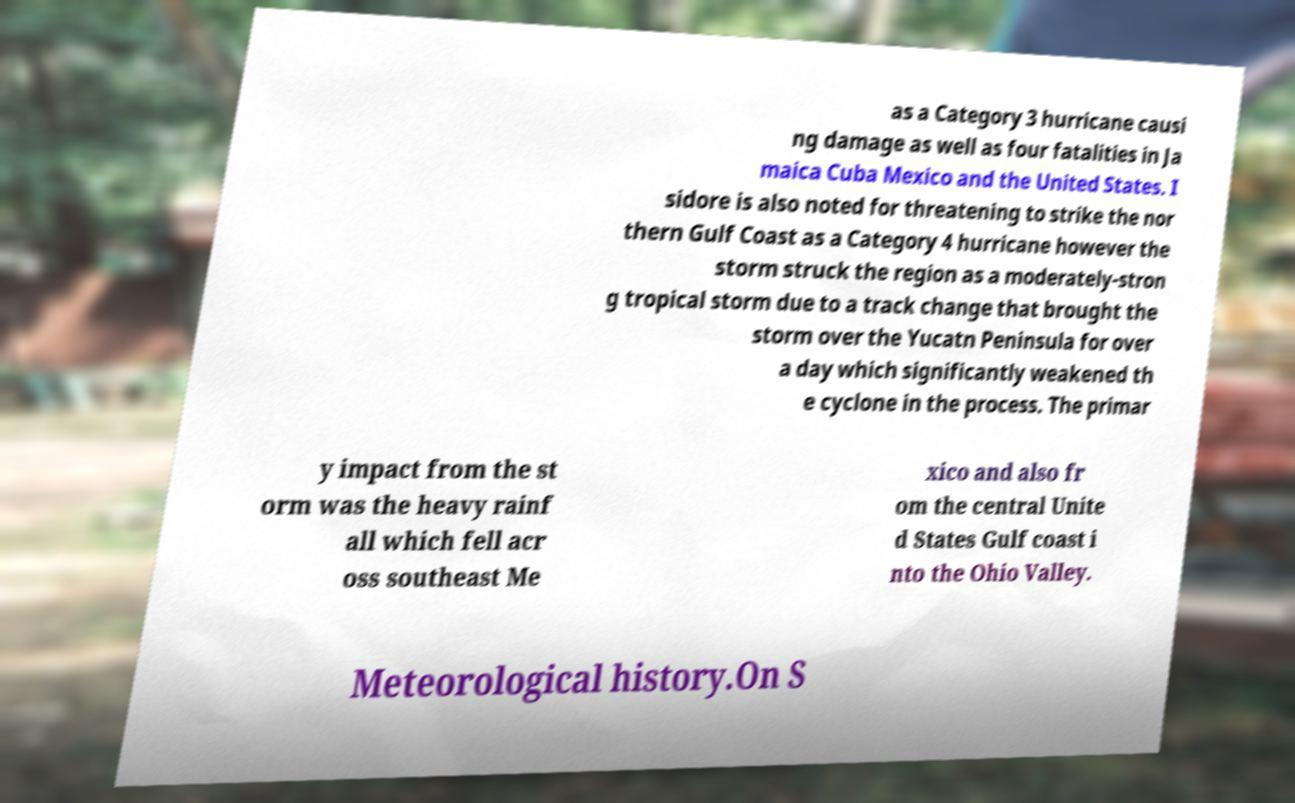What messages or text are displayed in this image? I need them in a readable, typed format. as a Category 3 hurricane causi ng damage as well as four fatalities in Ja maica Cuba Mexico and the United States. I sidore is also noted for threatening to strike the nor thern Gulf Coast as a Category 4 hurricane however the storm struck the region as a moderately-stron g tropical storm due to a track change that brought the storm over the Yucatn Peninsula for over a day which significantly weakened th e cyclone in the process. The primar y impact from the st orm was the heavy rainf all which fell acr oss southeast Me xico and also fr om the central Unite d States Gulf coast i nto the Ohio Valley. Meteorological history.On S 